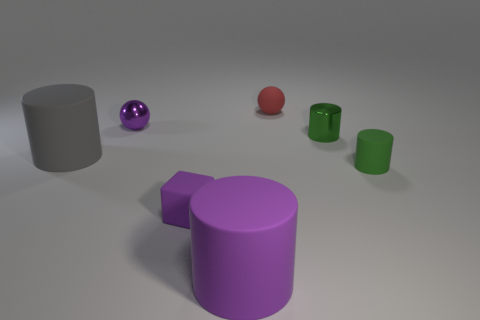Is the shape of the green metal thing that is on the left side of the tiny matte cylinder the same as the purple rubber object to the left of the large purple thing?
Ensure brevity in your answer.  No. What number of things are matte objects or big cylinders behind the cube?
Provide a short and direct response. 5. What number of other things are there of the same shape as the gray matte thing?
Your response must be concise. 3. Is the material of the small green cylinder on the right side of the metal cylinder the same as the large purple cylinder?
Provide a succinct answer. Yes. What number of objects are tiny cylinders or small cyan rubber objects?
Your response must be concise. 2. What size is the purple thing that is the same shape as the gray matte thing?
Your answer should be compact. Large. What is the size of the red thing?
Offer a terse response. Small. Is the number of tiny purple rubber things to the right of the small purple shiny thing greater than the number of matte cylinders?
Offer a very short reply. No. Are there any other things that have the same material as the large gray cylinder?
Your response must be concise. Yes. Does the object behind the shiny ball have the same color as the matte cylinder on the left side of the small purple ball?
Offer a very short reply. No. 